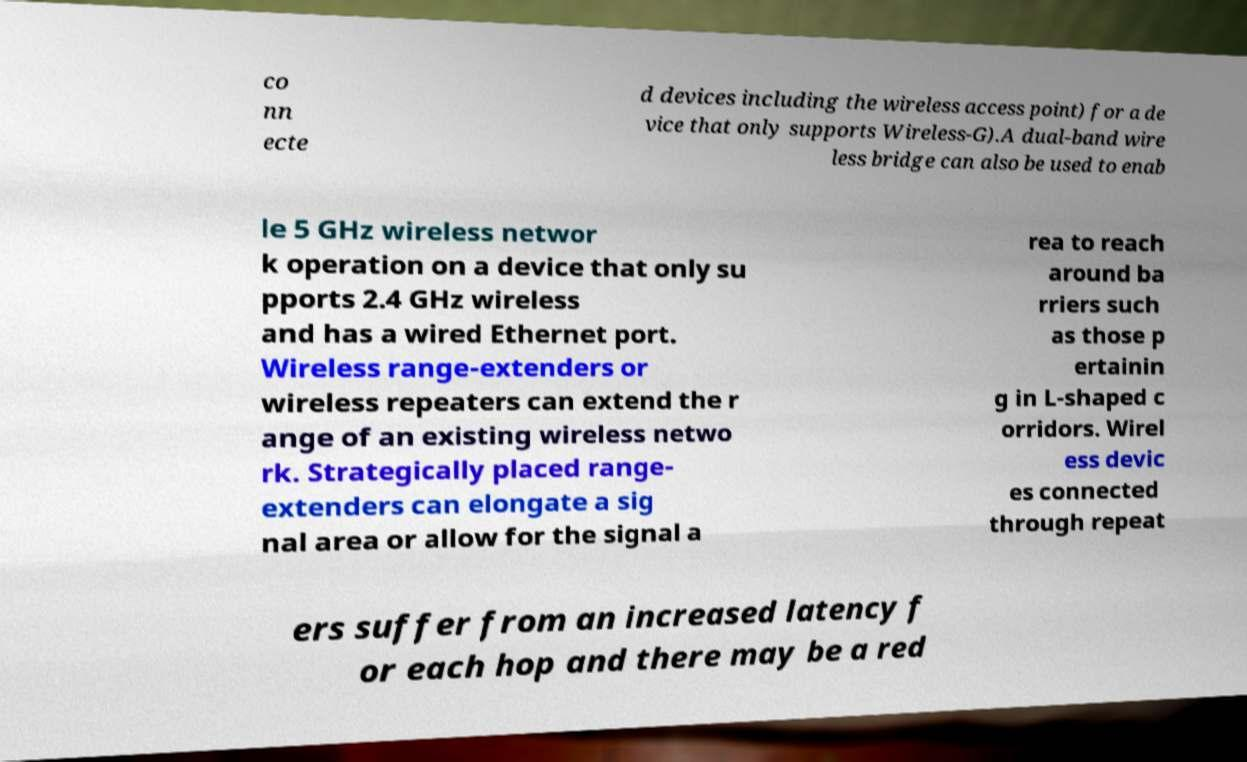What messages or text are displayed in this image? I need them in a readable, typed format. co nn ecte d devices including the wireless access point) for a de vice that only supports Wireless-G).A dual-band wire less bridge can also be used to enab le 5 GHz wireless networ k operation on a device that only su pports 2.4 GHz wireless and has a wired Ethernet port. Wireless range-extenders or wireless repeaters can extend the r ange of an existing wireless netwo rk. Strategically placed range- extenders can elongate a sig nal area or allow for the signal a rea to reach around ba rriers such as those p ertainin g in L-shaped c orridors. Wirel ess devic es connected through repeat ers suffer from an increased latency f or each hop and there may be a red 